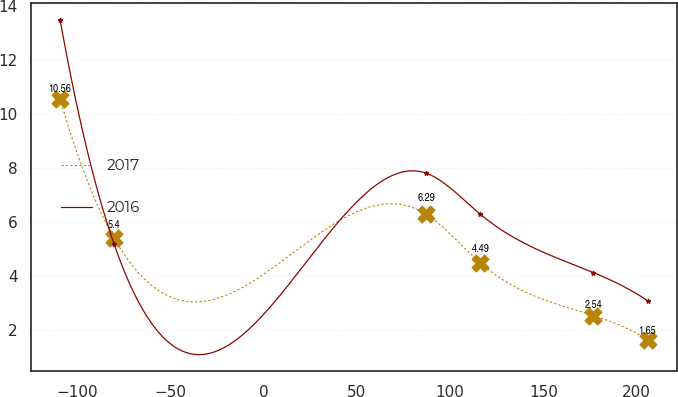Convert chart to OTSL. <chart><loc_0><loc_0><loc_500><loc_500><line_chart><ecel><fcel>2017<fcel>2016<nl><fcel>-109.15<fcel>10.56<fcel>13.49<nl><fcel>-80.14<fcel>5.4<fcel>5.17<nl><fcel>87.14<fcel>6.29<fcel>7.81<nl><fcel>116.15<fcel>4.49<fcel>6.29<nl><fcel>176.79<fcel>2.54<fcel>4.13<nl><fcel>205.8<fcel>1.65<fcel>3.09<nl></chart> 